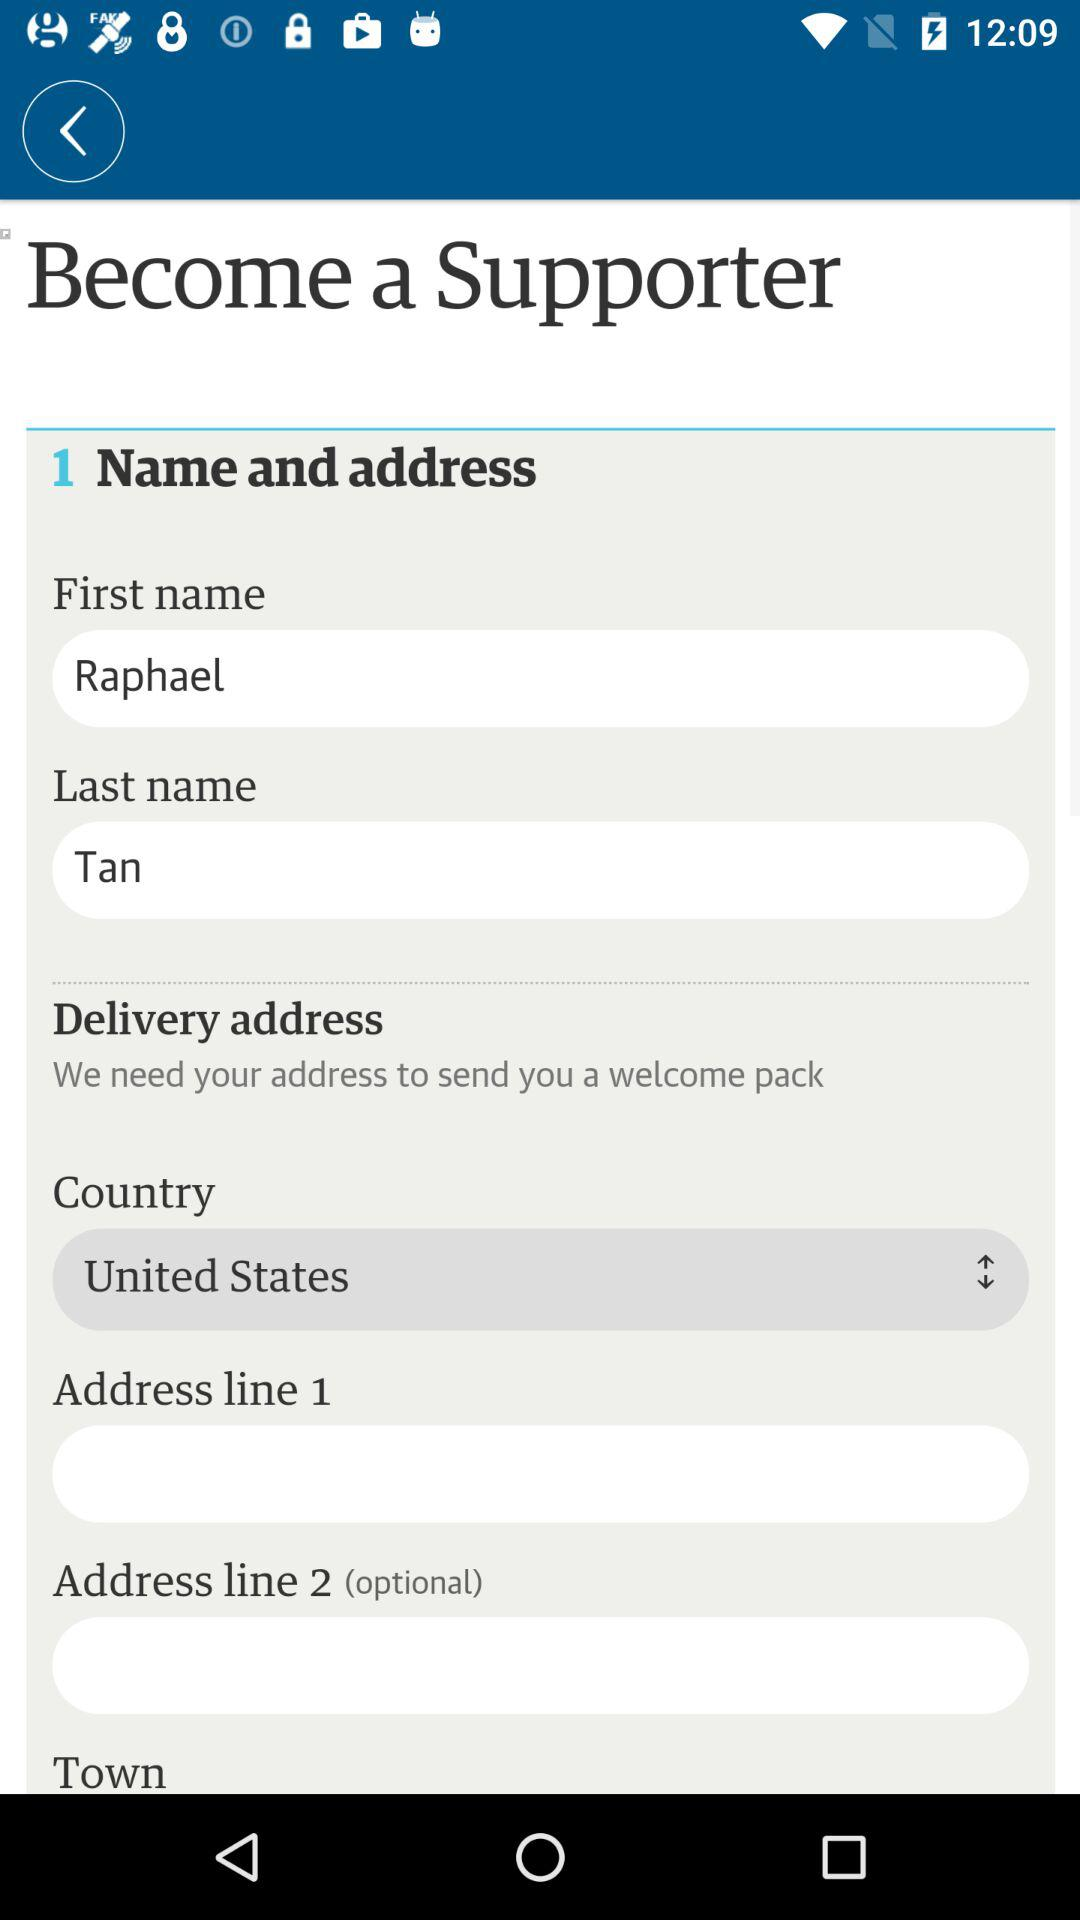What is the selected country? The selected country is the United States. 